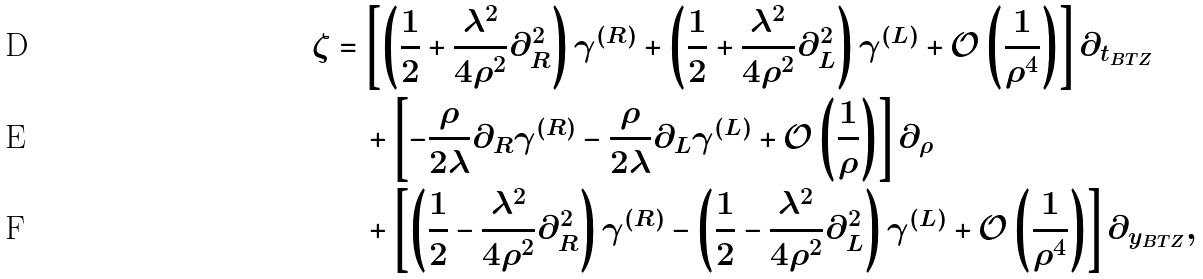<formula> <loc_0><loc_0><loc_500><loc_500>\zeta & = \left [ \left ( \frac { 1 } { 2 } + \frac { \lambda ^ { 2 } } { 4 \rho ^ { 2 } } \partial _ { R } ^ { 2 } \right ) \gamma ^ { ( R ) } + \left ( \frac { 1 } { 2 } + \frac { \lambda ^ { 2 } } { 4 \rho ^ { 2 } } \partial _ { L } ^ { 2 } \right ) \gamma ^ { ( L ) } + \mathcal { O } \left ( \frac { 1 } { \rho ^ { 4 } } \right ) \right ] \partial _ { t _ { B T Z } } \\ & \quad + \left [ - \frac { \rho } { 2 \lambda } \partial _ { R } \gamma ^ { ( R ) } - \frac { \rho } { 2 \lambda } \partial _ { L } \gamma ^ { ( L ) } + \mathcal { O } \left ( \frac { 1 } { \rho } \right ) \right ] \partial _ { \rho } \\ & \quad + \left [ \left ( \frac { 1 } { 2 } - \frac { \lambda ^ { 2 } } { 4 \rho ^ { 2 } } \partial _ { R } ^ { 2 } \right ) \gamma ^ { ( R ) } - \left ( \frac { 1 } { 2 } - \frac { \lambda ^ { 2 } } { 4 \rho ^ { 2 } } \partial _ { L } ^ { 2 } \right ) \gamma ^ { ( L ) } + \mathcal { O } \left ( \frac { 1 } { \rho ^ { 4 } } \right ) \right ] \partial _ { y _ { B T Z } } ,</formula> 